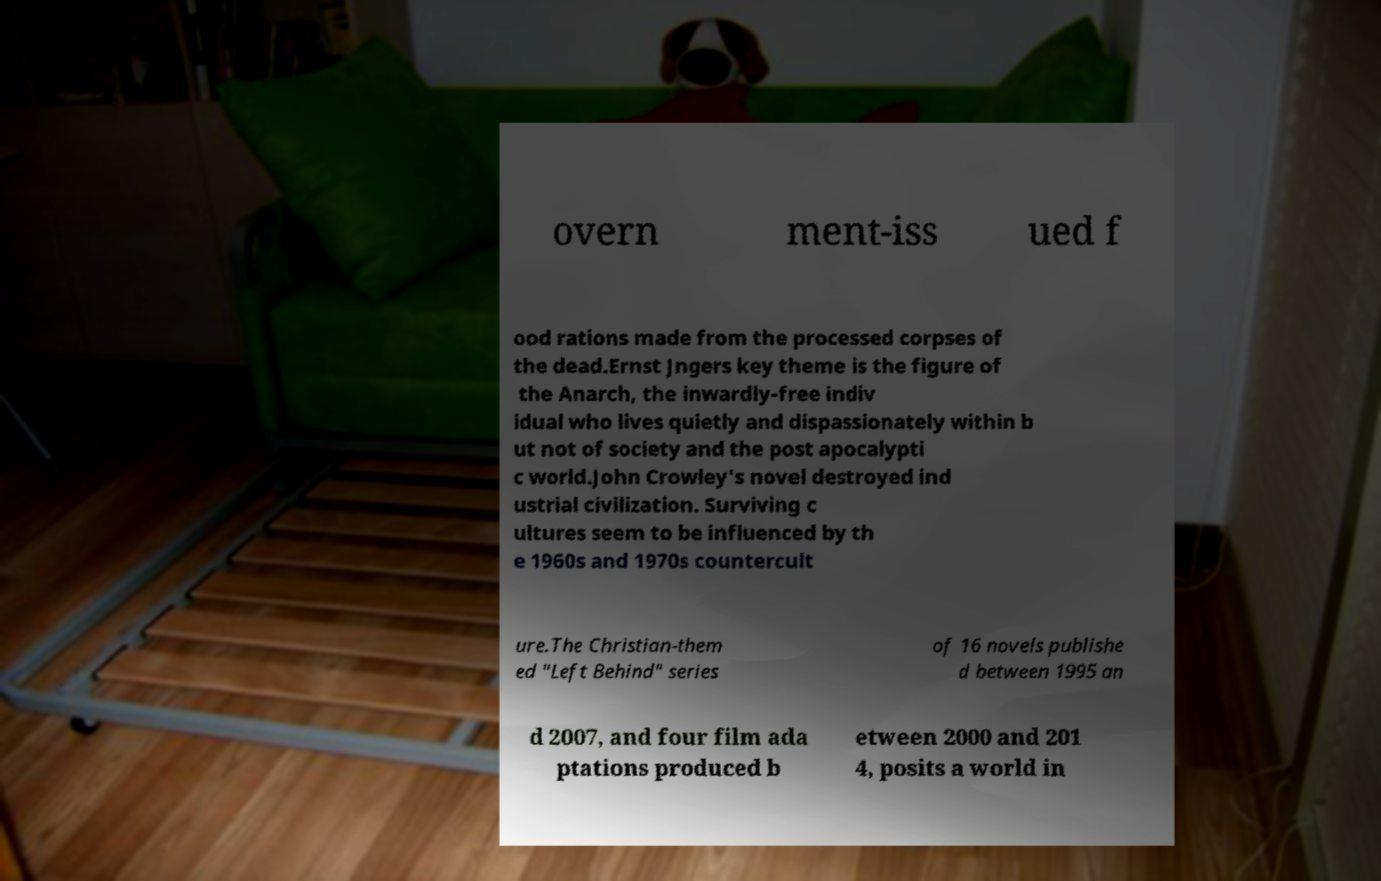Can you accurately transcribe the text from the provided image for me? overn ment-iss ued f ood rations made from the processed corpses of the dead.Ernst Jngers key theme is the figure of the Anarch, the inwardly-free indiv idual who lives quietly and dispassionately within b ut not of society and the post apocalypti c world.John Crowley's novel destroyed ind ustrial civilization. Surviving c ultures seem to be influenced by th e 1960s and 1970s countercult ure.The Christian-them ed "Left Behind" series of 16 novels publishe d between 1995 an d 2007, and four film ada ptations produced b etween 2000 and 201 4, posits a world in 